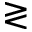<formula> <loc_0><loc_0><loc_500><loc_500>\gtrless</formula> 